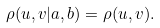Convert formula to latex. <formula><loc_0><loc_0><loc_500><loc_500>\rho ( u , v | a , b ) = \rho ( u , v ) .</formula> 